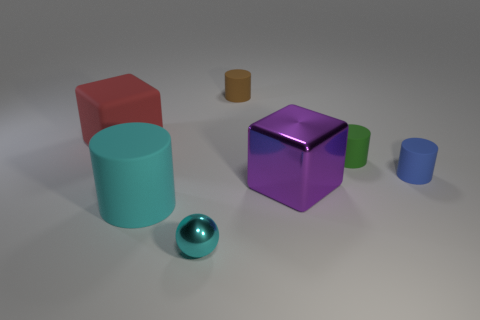Is the size of the brown rubber cylinder the same as the purple shiny object?
Make the answer very short. No. There is a large object on the right side of the matte cylinder that is behind the matte block; what is its material?
Offer a terse response. Metal. Is the shape of the shiny object that is to the left of the brown matte thing the same as the object behind the red rubber block?
Ensure brevity in your answer.  No. Is the number of large cyan matte objects that are behind the large cyan cylinder the same as the number of large cyan rubber cylinders?
Provide a short and direct response. No. Are there any purple things behind the purple thing that is to the left of the green rubber cylinder?
Make the answer very short. No. Is there anything else that is the same color as the large shiny cube?
Provide a succinct answer. No. Is the material of the cube behind the big shiny block the same as the large cyan cylinder?
Provide a short and direct response. Yes. Is the number of blue objects left of the small brown cylinder the same as the number of small objects on the left side of the big cyan rubber thing?
Give a very brief answer. Yes. There is a purple metal block in front of the block that is on the left side of the tiny brown cylinder; how big is it?
Provide a succinct answer. Large. The big object that is in front of the red cube and to the left of the brown cylinder is made of what material?
Provide a succinct answer. Rubber. 